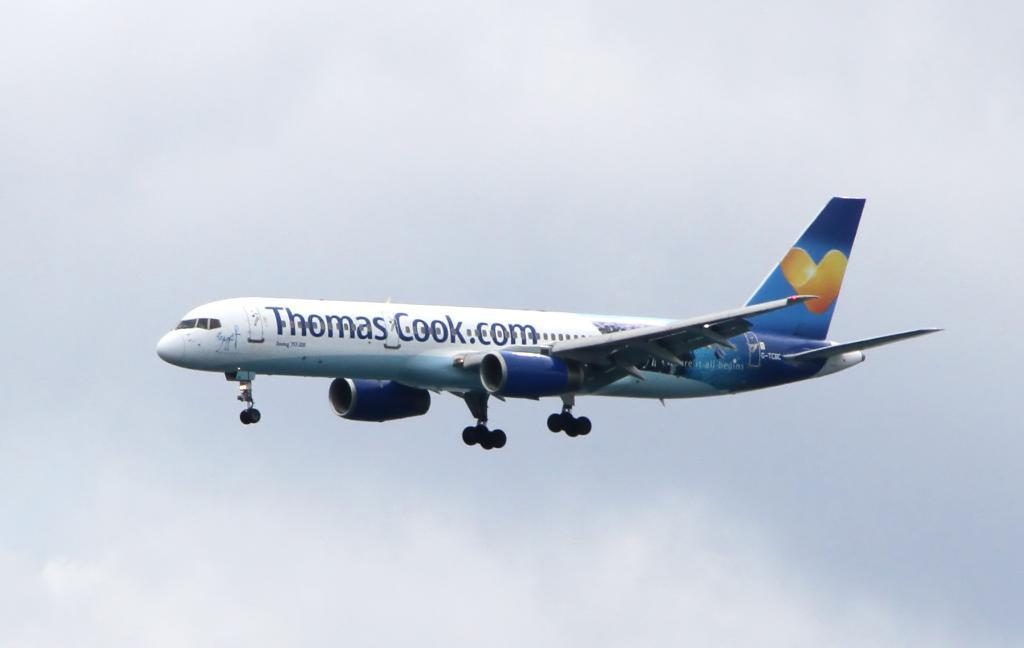<image>
Describe the image concisely. A Thomas Cook.com airplane in a cloudy sky. 